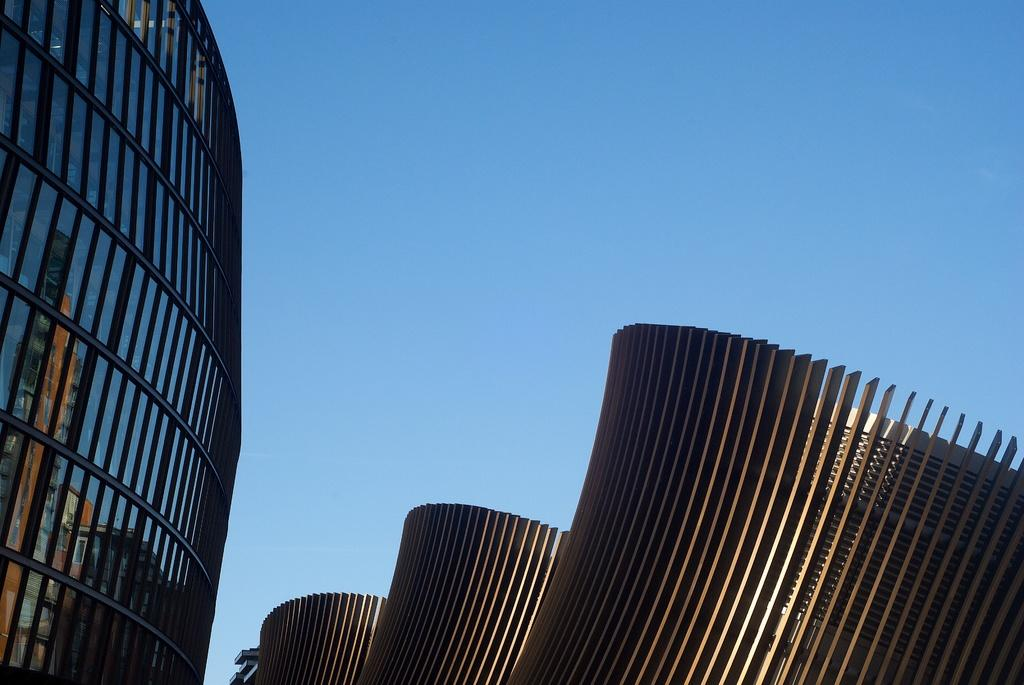What structures can be seen in the image? There are buildings in the image. What part of the natural environment is visible in the image? The sky is visible in the background of the image. What type of cast can be seen on the dog in the image? There is no dog present in the image, and therefore no cast can be observed. 